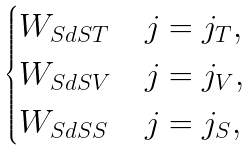Convert formula to latex. <formula><loc_0><loc_0><loc_500><loc_500>\begin{cases} W _ { S d S T } & \text {$j=j_{T}$} , \\ W _ { S d S V } & \text {$j=j_{V}$} , \\ W _ { S d S S } & \text {$j=j_{S}$} , \end{cases}</formula> 